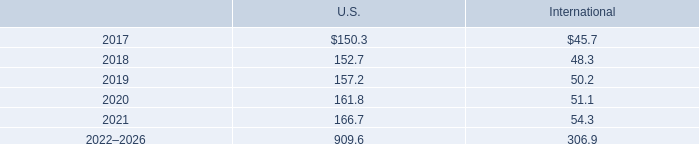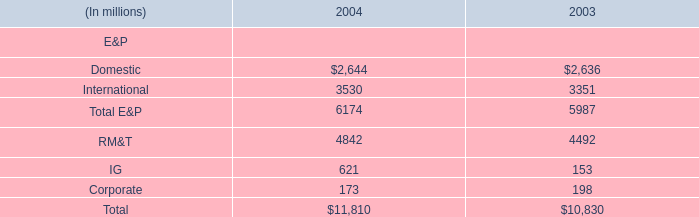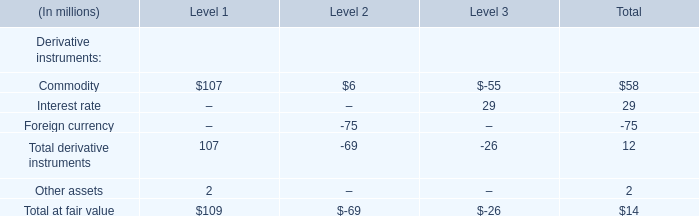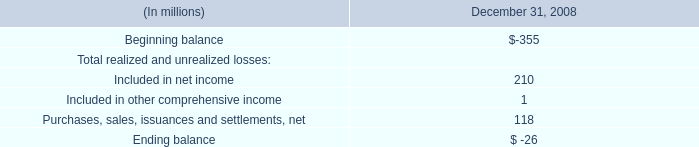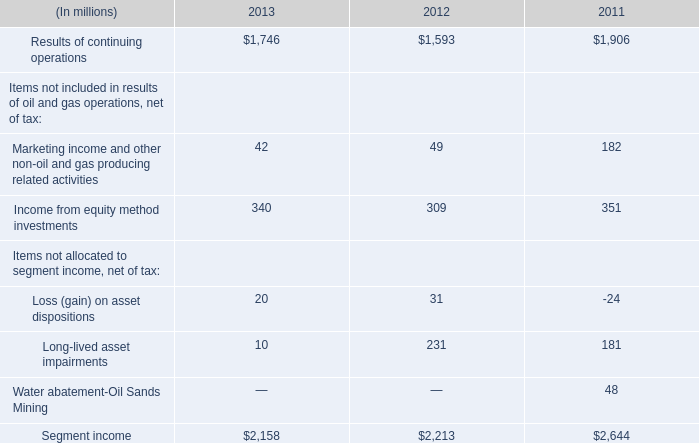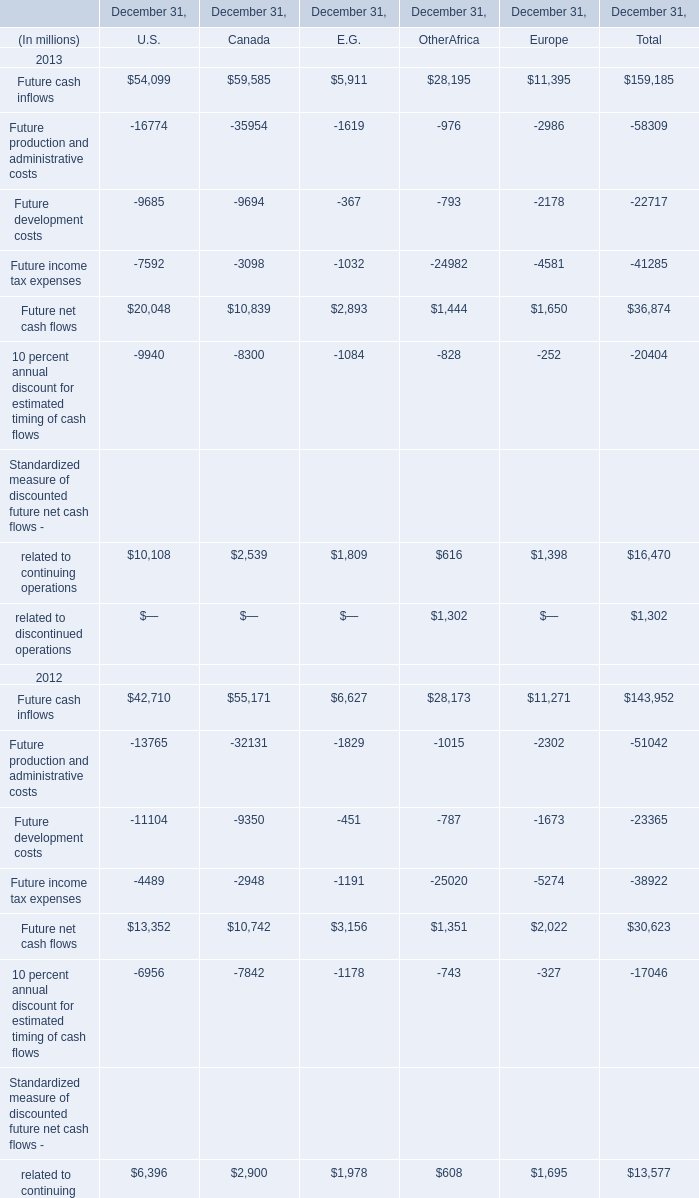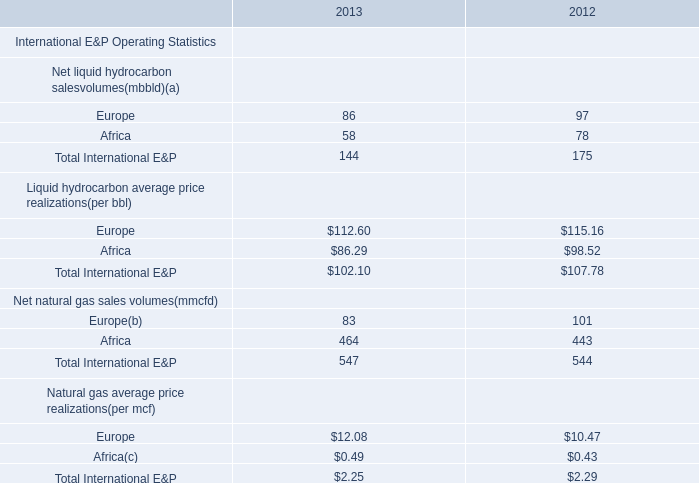What's the increasing rate of Income from equity method investments in 2013? 
Computations: ((340 - 309) / 309)
Answer: 0.10032. 